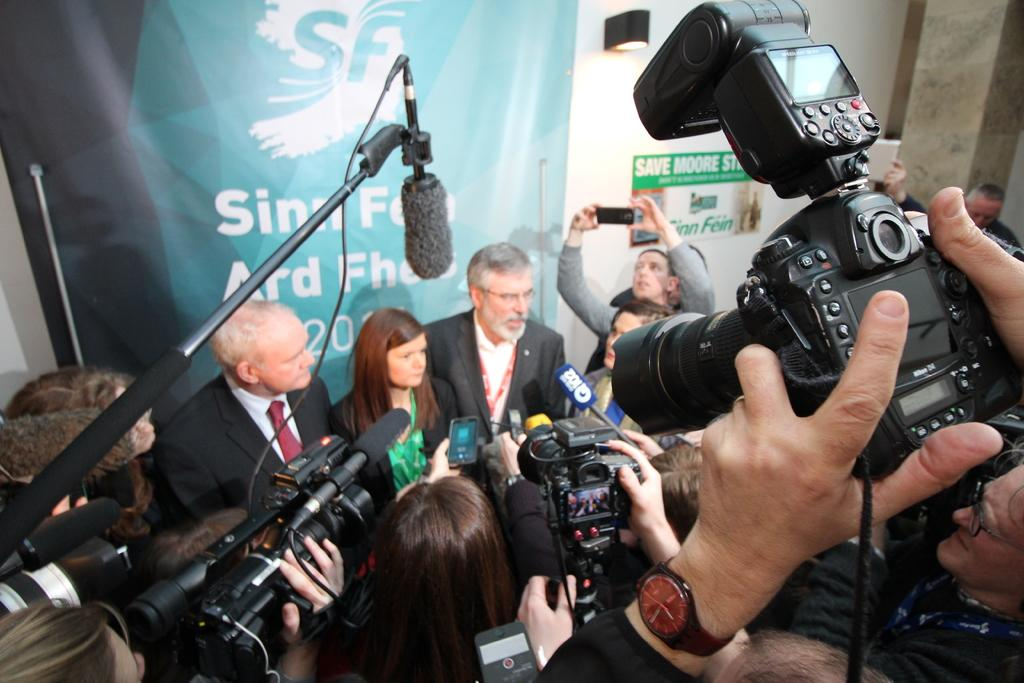What is happening in the image? There is a group of people in the image. What are some of the people in the group doing? Some people in the group are capturing with cameras, while others are holding microphones. What type of insect is crawling on the father's shoulder in the image? There is no father or insect present in the image. 